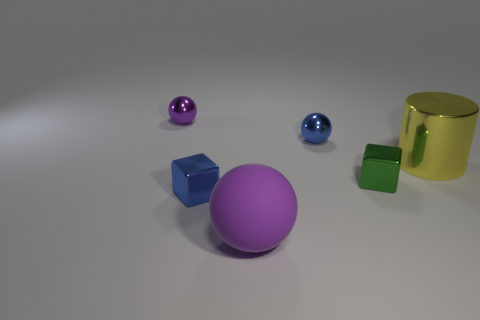Subtract all cyan cubes. Subtract all brown cylinders. How many cubes are left? 2 Add 2 purple spheres. How many objects exist? 8 Subtract all blocks. How many objects are left? 4 Add 3 metal cylinders. How many metal cylinders are left? 4 Add 2 large metallic cylinders. How many large metallic cylinders exist? 3 Subtract 0 brown cylinders. How many objects are left? 6 Subtract all gray shiny things. Subtract all small blue metallic cubes. How many objects are left? 5 